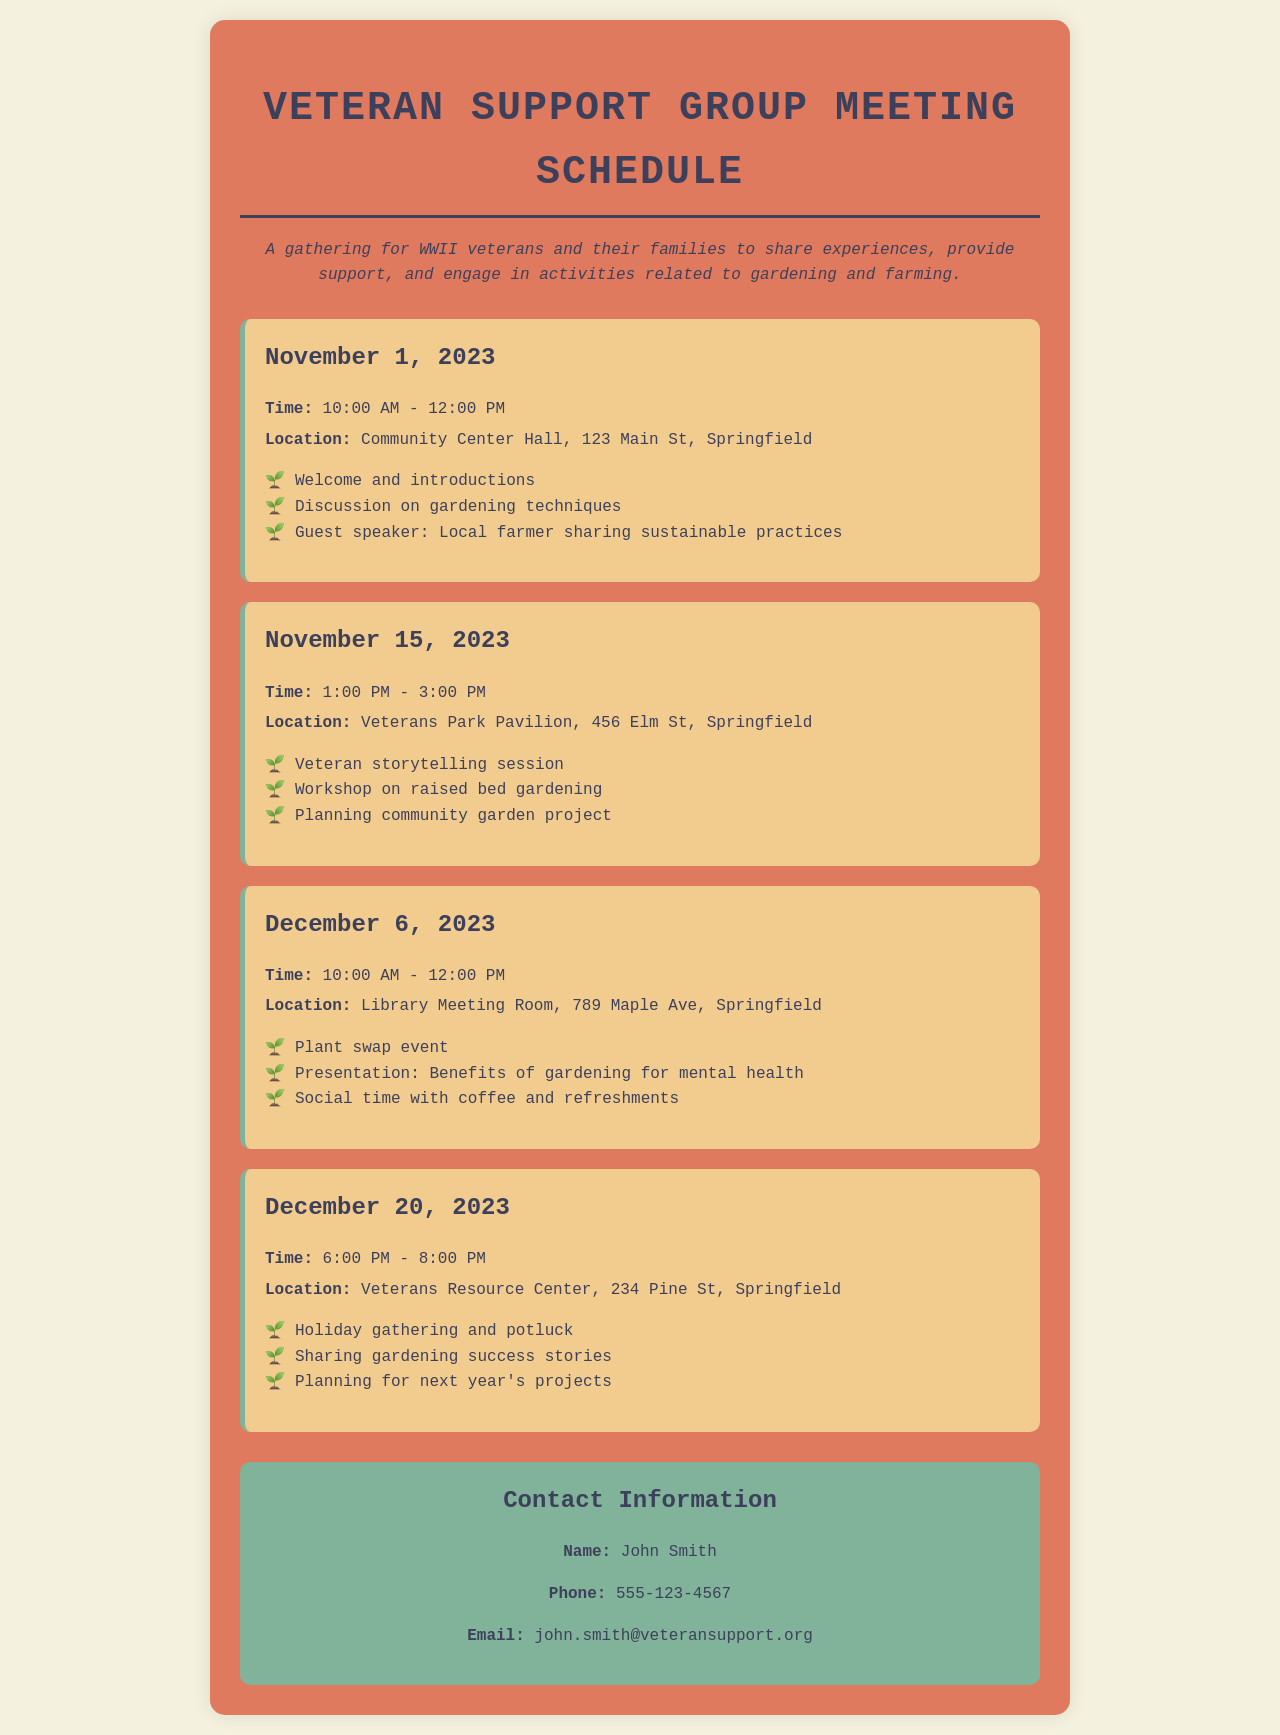What is the title of the document? The title is displayed prominently at the top of the document.
Answer: Veteran Support Group Meeting Schedule What is the time of the meeting on November 15, 2023? The document specifies the time for each meeting.
Answer: 1:00 PM - 3:00 PM Where is the meeting on December 6, 2023, held? Each meeting includes a specified location.
Answer: Library Meeting Room, 789 Maple Ave, Springfield Who is the guest speaker on November 1, 2023? The guest speaker is mentioned in the activities for that date.
Answer: Local farmer What activity is scheduled for December 20, 2023? Each meeting lists its activities, including special events.
Answer: Holiday gathering and potluck Which two topics are covered on November 15, 2023? The activities for that meeting are detailed in a list format.
Answer: Veteran storytelling session, Workshop on raised bed gardening How many meetings are scheduled before the end of 2023? The total number of meetings listed helps determine the total before year-end.
Answer: Four What is the contact person's phone number? The contact information section includes a phone number.
Answer: 555-123-4567 What is the focus of the gathering as described in the document? The description provides insight into the overall aim of the meetings.
Answer: Share experiences, provide support, and engage in activities related to gardening and farming 